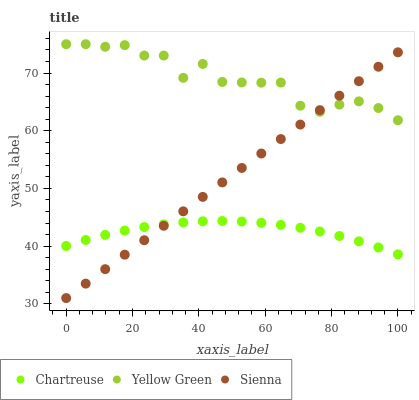Does Chartreuse have the minimum area under the curve?
Answer yes or no. Yes. Does Yellow Green have the maximum area under the curve?
Answer yes or no. Yes. Does Yellow Green have the minimum area under the curve?
Answer yes or no. No. Does Chartreuse have the maximum area under the curve?
Answer yes or no. No. Is Sienna the smoothest?
Answer yes or no. Yes. Is Yellow Green the roughest?
Answer yes or no. Yes. Is Chartreuse the smoothest?
Answer yes or no. No. Is Chartreuse the roughest?
Answer yes or no. No. Does Sienna have the lowest value?
Answer yes or no. Yes. Does Chartreuse have the lowest value?
Answer yes or no. No. Does Yellow Green have the highest value?
Answer yes or no. Yes. Does Chartreuse have the highest value?
Answer yes or no. No. Is Chartreuse less than Yellow Green?
Answer yes or no. Yes. Is Yellow Green greater than Chartreuse?
Answer yes or no. Yes. Does Yellow Green intersect Sienna?
Answer yes or no. Yes. Is Yellow Green less than Sienna?
Answer yes or no. No. Is Yellow Green greater than Sienna?
Answer yes or no. No. Does Chartreuse intersect Yellow Green?
Answer yes or no. No. 